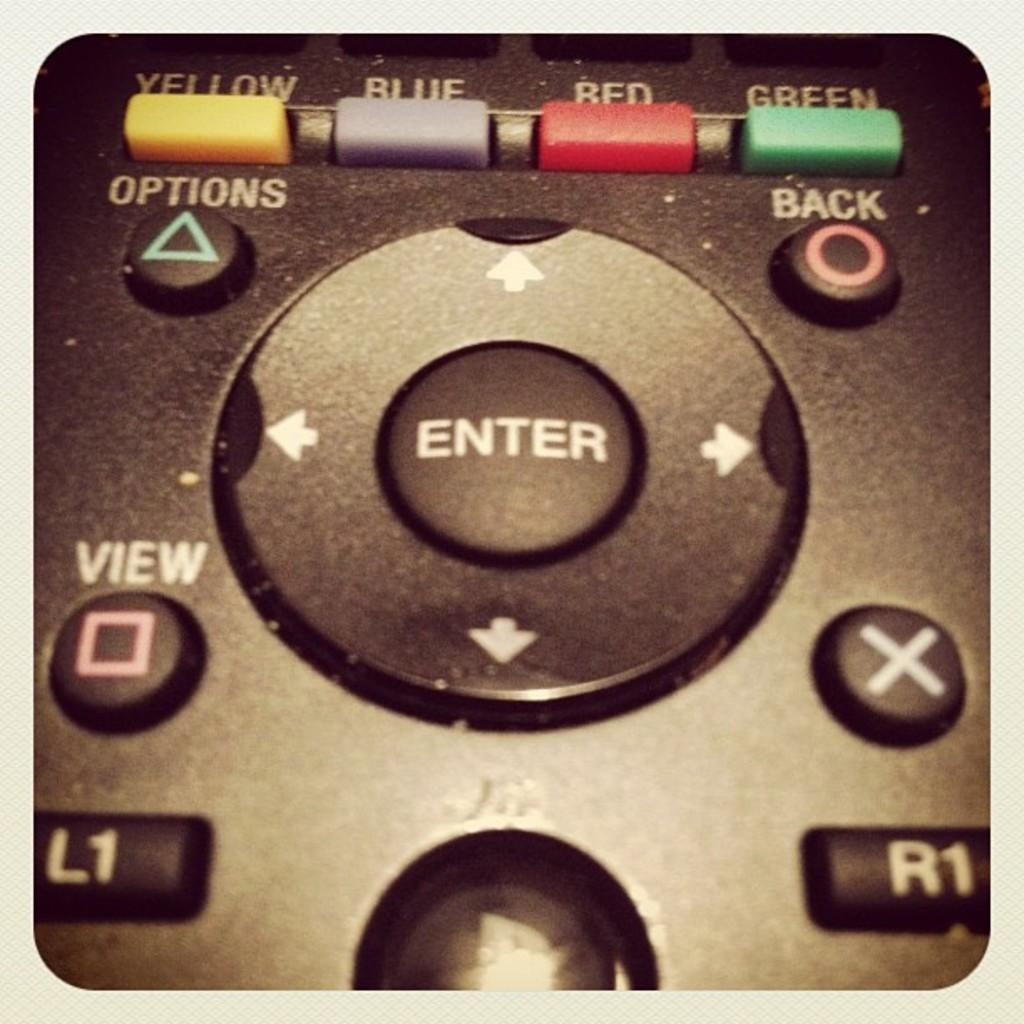Provide a one-sentence caption for the provided image. A colse up of an old video game controller with blue, red and green buttons as well as enter and x buttons. 